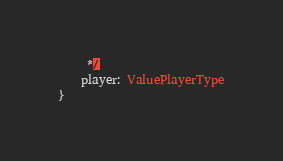Convert code to text. <code><loc_0><loc_0><loc_500><loc_500><_TypeScript_>     */
    player: ValuePlayerType
}</code> 